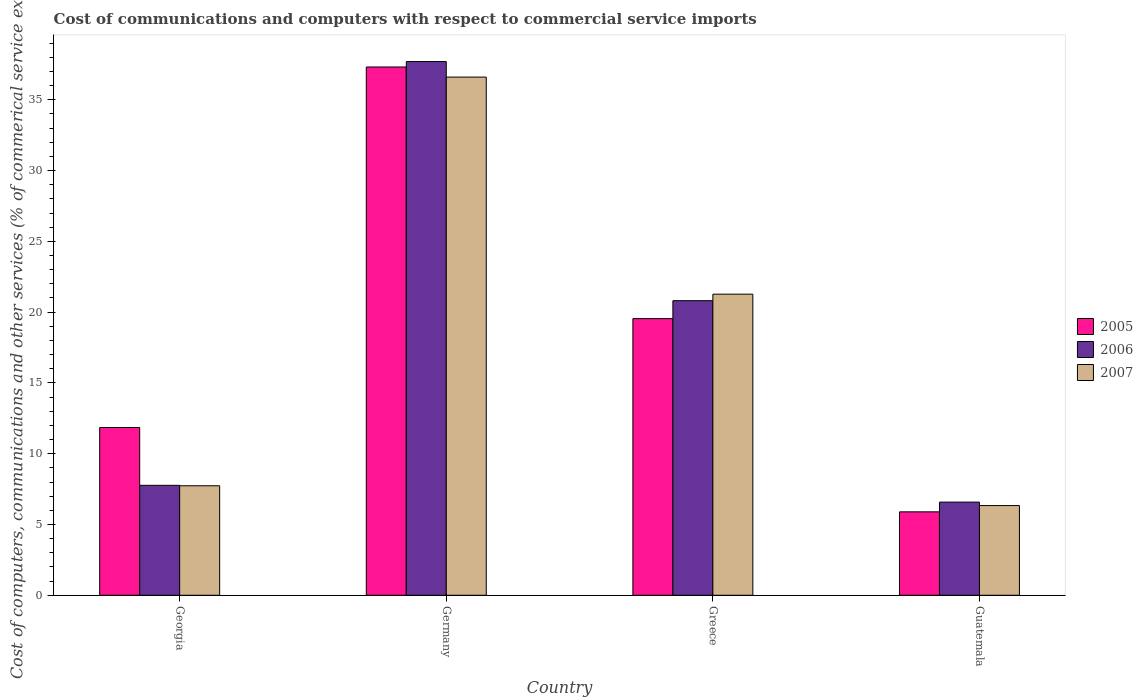How many bars are there on the 4th tick from the right?
Keep it short and to the point. 3. What is the label of the 4th group of bars from the left?
Your answer should be very brief. Guatemala. In how many cases, is the number of bars for a given country not equal to the number of legend labels?
Keep it short and to the point. 0. What is the cost of communications and computers in 2005 in Guatemala?
Your answer should be very brief. 5.89. Across all countries, what is the maximum cost of communications and computers in 2007?
Provide a short and direct response. 36.6. Across all countries, what is the minimum cost of communications and computers in 2006?
Give a very brief answer. 6.58. In which country was the cost of communications and computers in 2006 maximum?
Provide a short and direct response. Germany. In which country was the cost of communications and computers in 2007 minimum?
Keep it short and to the point. Guatemala. What is the total cost of communications and computers in 2005 in the graph?
Your response must be concise. 74.61. What is the difference between the cost of communications and computers in 2005 in Greece and that in Guatemala?
Keep it short and to the point. 13.65. What is the difference between the cost of communications and computers in 2005 in Guatemala and the cost of communications and computers in 2006 in Greece?
Offer a very short reply. -14.92. What is the average cost of communications and computers in 2005 per country?
Give a very brief answer. 18.65. What is the difference between the cost of communications and computers of/in 2006 and cost of communications and computers of/in 2005 in Guatemala?
Provide a short and direct response. 0.69. What is the ratio of the cost of communications and computers in 2005 in Germany to that in Greece?
Your answer should be compact. 1.91. Is the difference between the cost of communications and computers in 2006 in Georgia and Greece greater than the difference between the cost of communications and computers in 2005 in Georgia and Greece?
Keep it short and to the point. No. What is the difference between the highest and the second highest cost of communications and computers in 2005?
Your response must be concise. -7.69. What is the difference between the highest and the lowest cost of communications and computers in 2007?
Provide a succinct answer. 30.27. In how many countries, is the cost of communications and computers in 2006 greater than the average cost of communications and computers in 2006 taken over all countries?
Your answer should be very brief. 2. Is the sum of the cost of communications and computers in 2005 in Germany and Greece greater than the maximum cost of communications and computers in 2007 across all countries?
Keep it short and to the point. Yes. What does the 2nd bar from the left in Greece represents?
Your answer should be compact. 2006. Is it the case that in every country, the sum of the cost of communications and computers in 2007 and cost of communications and computers in 2006 is greater than the cost of communications and computers in 2005?
Offer a very short reply. Yes. How many countries are there in the graph?
Your answer should be very brief. 4. What is the difference between two consecutive major ticks on the Y-axis?
Your answer should be compact. 5. Where does the legend appear in the graph?
Provide a succinct answer. Center right. What is the title of the graph?
Keep it short and to the point. Cost of communications and computers with respect to commercial service imports. Does "1970" appear as one of the legend labels in the graph?
Offer a terse response. No. What is the label or title of the X-axis?
Your answer should be compact. Country. What is the label or title of the Y-axis?
Your answer should be very brief. Cost of computers, communications and other services (% of commerical service exports). What is the Cost of computers, communications and other services (% of commerical service exports) in 2005 in Georgia?
Make the answer very short. 11.85. What is the Cost of computers, communications and other services (% of commerical service exports) in 2006 in Georgia?
Provide a short and direct response. 7.77. What is the Cost of computers, communications and other services (% of commerical service exports) in 2007 in Georgia?
Your answer should be compact. 7.73. What is the Cost of computers, communications and other services (% of commerical service exports) of 2005 in Germany?
Give a very brief answer. 37.32. What is the Cost of computers, communications and other services (% of commerical service exports) of 2006 in Germany?
Your answer should be compact. 37.7. What is the Cost of computers, communications and other services (% of commerical service exports) in 2007 in Germany?
Offer a very short reply. 36.6. What is the Cost of computers, communications and other services (% of commerical service exports) of 2005 in Greece?
Offer a very short reply. 19.54. What is the Cost of computers, communications and other services (% of commerical service exports) in 2006 in Greece?
Offer a very short reply. 20.81. What is the Cost of computers, communications and other services (% of commerical service exports) of 2007 in Greece?
Your answer should be very brief. 21.27. What is the Cost of computers, communications and other services (% of commerical service exports) in 2005 in Guatemala?
Your response must be concise. 5.89. What is the Cost of computers, communications and other services (% of commerical service exports) in 2006 in Guatemala?
Keep it short and to the point. 6.58. What is the Cost of computers, communications and other services (% of commerical service exports) in 2007 in Guatemala?
Keep it short and to the point. 6.34. Across all countries, what is the maximum Cost of computers, communications and other services (% of commerical service exports) in 2005?
Provide a succinct answer. 37.32. Across all countries, what is the maximum Cost of computers, communications and other services (% of commerical service exports) in 2006?
Give a very brief answer. 37.7. Across all countries, what is the maximum Cost of computers, communications and other services (% of commerical service exports) in 2007?
Ensure brevity in your answer.  36.6. Across all countries, what is the minimum Cost of computers, communications and other services (% of commerical service exports) of 2005?
Provide a succinct answer. 5.89. Across all countries, what is the minimum Cost of computers, communications and other services (% of commerical service exports) in 2006?
Make the answer very short. 6.58. Across all countries, what is the minimum Cost of computers, communications and other services (% of commerical service exports) in 2007?
Your answer should be compact. 6.34. What is the total Cost of computers, communications and other services (% of commerical service exports) in 2005 in the graph?
Offer a terse response. 74.61. What is the total Cost of computers, communications and other services (% of commerical service exports) in 2006 in the graph?
Your response must be concise. 72.86. What is the total Cost of computers, communications and other services (% of commerical service exports) in 2007 in the graph?
Provide a short and direct response. 71.95. What is the difference between the Cost of computers, communications and other services (% of commerical service exports) in 2005 in Georgia and that in Germany?
Your answer should be very brief. -25.46. What is the difference between the Cost of computers, communications and other services (% of commerical service exports) of 2006 in Georgia and that in Germany?
Your response must be concise. -29.93. What is the difference between the Cost of computers, communications and other services (% of commerical service exports) of 2007 in Georgia and that in Germany?
Your answer should be very brief. -28.87. What is the difference between the Cost of computers, communications and other services (% of commerical service exports) in 2005 in Georgia and that in Greece?
Your response must be concise. -7.69. What is the difference between the Cost of computers, communications and other services (% of commerical service exports) in 2006 in Georgia and that in Greece?
Offer a terse response. -13.04. What is the difference between the Cost of computers, communications and other services (% of commerical service exports) of 2007 in Georgia and that in Greece?
Provide a short and direct response. -13.54. What is the difference between the Cost of computers, communications and other services (% of commerical service exports) in 2005 in Georgia and that in Guatemala?
Give a very brief answer. 5.96. What is the difference between the Cost of computers, communications and other services (% of commerical service exports) in 2006 in Georgia and that in Guatemala?
Offer a very short reply. 1.18. What is the difference between the Cost of computers, communications and other services (% of commerical service exports) of 2007 in Georgia and that in Guatemala?
Offer a terse response. 1.4. What is the difference between the Cost of computers, communications and other services (% of commerical service exports) in 2005 in Germany and that in Greece?
Provide a short and direct response. 17.77. What is the difference between the Cost of computers, communications and other services (% of commerical service exports) in 2006 in Germany and that in Greece?
Offer a terse response. 16.89. What is the difference between the Cost of computers, communications and other services (% of commerical service exports) of 2007 in Germany and that in Greece?
Ensure brevity in your answer.  15.33. What is the difference between the Cost of computers, communications and other services (% of commerical service exports) of 2005 in Germany and that in Guatemala?
Provide a short and direct response. 31.42. What is the difference between the Cost of computers, communications and other services (% of commerical service exports) in 2006 in Germany and that in Guatemala?
Ensure brevity in your answer.  31.12. What is the difference between the Cost of computers, communications and other services (% of commerical service exports) of 2007 in Germany and that in Guatemala?
Provide a succinct answer. 30.27. What is the difference between the Cost of computers, communications and other services (% of commerical service exports) of 2005 in Greece and that in Guatemala?
Your answer should be compact. 13.65. What is the difference between the Cost of computers, communications and other services (% of commerical service exports) of 2006 in Greece and that in Guatemala?
Keep it short and to the point. 14.23. What is the difference between the Cost of computers, communications and other services (% of commerical service exports) of 2007 in Greece and that in Guatemala?
Ensure brevity in your answer.  14.93. What is the difference between the Cost of computers, communications and other services (% of commerical service exports) in 2005 in Georgia and the Cost of computers, communications and other services (% of commerical service exports) in 2006 in Germany?
Your answer should be compact. -25.85. What is the difference between the Cost of computers, communications and other services (% of commerical service exports) of 2005 in Georgia and the Cost of computers, communications and other services (% of commerical service exports) of 2007 in Germany?
Your answer should be compact. -24.75. What is the difference between the Cost of computers, communications and other services (% of commerical service exports) in 2006 in Georgia and the Cost of computers, communications and other services (% of commerical service exports) in 2007 in Germany?
Your answer should be compact. -28.84. What is the difference between the Cost of computers, communications and other services (% of commerical service exports) of 2005 in Georgia and the Cost of computers, communications and other services (% of commerical service exports) of 2006 in Greece?
Make the answer very short. -8.96. What is the difference between the Cost of computers, communications and other services (% of commerical service exports) in 2005 in Georgia and the Cost of computers, communications and other services (% of commerical service exports) in 2007 in Greece?
Your response must be concise. -9.42. What is the difference between the Cost of computers, communications and other services (% of commerical service exports) in 2006 in Georgia and the Cost of computers, communications and other services (% of commerical service exports) in 2007 in Greece?
Give a very brief answer. -13.5. What is the difference between the Cost of computers, communications and other services (% of commerical service exports) in 2005 in Georgia and the Cost of computers, communications and other services (% of commerical service exports) in 2006 in Guatemala?
Your answer should be compact. 5.27. What is the difference between the Cost of computers, communications and other services (% of commerical service exports) in 2005 in Georgia and the Cost of computers, communications and other services (% of commerical service exports) in 2007 in Guatemala?
Your answer should be compact. 5.52. What is the difference between the Cost of computers, communications and other services (% of commerical service exports) in 2006 in Georgia and the Cost of computers, communications and other services (% of commerical service exports) in 2007 in Guatemala?
Offer a very short reply. 1.43. What is the difference between the Cost of computers, communications and other services (% of commerical service exports) of 2005 in Germany and the Cost of computers, communications and other services (% of commerical service exports) of 2006 in Greece?
Give a very brief answer. 16.51. What is the difference between the Cost of computers, communications and other services (% of commerical service exports) in 2005 in Germany and the Cost of computers, communications and other services (% of commerical service exports) in 2007 in Greece?
Make the answer very short. 16.05. What is the difference between the Cost of computers, communications and other services (% of commerical service exports) of 2006 in Germany and the Cost of computers, communications and other services (% of commerical service exports) of 2007 in Greece?
Your answer should be very brief. 16.43. What is the difference between the Cost of computers, communications and other services (% of commerical service exports) in 2005 in Germany and the Cost of computers, communications and other services (% of commerical service exports) in 2006 in Guatemala?
Keep it short and to the point. 30.74. What is the difference between the Cost of computers, communications and other services (% of commerical service exports) of 2005 in Germany and the Cost of computers, communications and other services (% of commerical service exports) of 2007 in Guatemala?
Your answer should be compact. 30.98. What is the difference between the Cost of computers, communications and other services (% of commerical service exports) in 2006 in Germany and the Cost of computers, communications and other services (% of commerical service exports) in 2007 in Guatemala?
Ensure brevity in your answer.  31.36. What is the difference between the Cost of computers, communications and other services (% of commerical service exports) in 2005 in Greece and the Cost of computers, communications and other services (% of commerical service exports) in 2006 in Guatemala?
Offer a terse response. 12.96. What is the difference between the Cost of computers, communications and other services (% of commerical service exports) in 2005 in Greece and the Cost of computers, communications and other services (% of commerical service exports) in 2007 in Guatemala?
Keep it short and to the point. 13.21. What is the difference between the Cost of computers, communications and other services (% of commerical service exports) in 2006 in Greece and the Cost of computers, communications and other services (% of commerical service exports) in 2007 in Guatemala?
Your answer should be compact. 14.47. What is the average Cost of computers, communications and other services (% of commerical service exports) of 2005 per country?
Keep it short and to the point. 18.65. What is the average Cost of computers, communications and other services (% of commerical service exports) of 2006 per country?
Make the answer very short. 18.21. What is the average Cost of computers, communications and other services (% of commerical service exports) in 2007 per country?
Provide a short and direct response. 17.99. What is the difference between the Cost of computers, communications and other services (% of commerical service exports) in 2005 and Cost of computers, communications and other services (% of commerical service exports) in 2006 in Georgia?
Ensure brevity in your answer.  4.09. What is the difference between the Cost of computers, communications and other services (% of commerical service exports) of 2005 and Cost of computers, communications and other services (% of commerical service exports) of 2007 in Georgia?
Ensure brevity in your answer.  4.12. What is the difference between the Cost of computers, communications and other services (% of commerical service exports) of 2006 and Cost of computers, communications and other services (% of commerical service exports) of 2007 in Georgia?
Give a very brief answer. 0.03. What is the difference between the Cost of computers, communications and other services (% of commerical service exports) of 2005 and Cost of computers, communications and other services (% of commerical service exports) of 2006 in Germany?
Ensure brevity in your answer.  -0.38. What is the difference between the Cost of computers, communications and other services (% of commerical service exports) in 2005 and Cost of computers, communications and other services (% of commerical service exports) in 2007 in Germany?
Make the answer very short. 0.71. What is the difference between the Cost of computers, communications and other services (% of commerical service exports) of 2006 and Cost of computers, communications and other services (% of commerical service exports) of 2007 in Germany?
Your answer should be very brief. 1.1. What is the difference between the Cost of computers, communications and other services (% of commerical service exports) in 2005 and Cost of computers, communications and other services (% of commerical service exports) in 2006 in Greece?
Provide a succinct answer. -1.27. What is the difference between the Cost of computers, communications and other services (% of commerical service exports) of 2005 and Cost of computers, communications and other services (% of commerical service exports) of 2007 in Greece?
Give a very brief answer. -1.73. What is the difference between the Cost of computers, communications and other services (% of commerical service exports) of 2006 and Cost of computers, communications and other services (% of commerical service exports) of 2007 in Greece?
Your answer should be very brief. -0.46. What is the difference between the Cost of computers, communications and other services (% of commerical service exports) of 2005 and Cost of computers, communications and other services (% of commerical service exports) of 2006 in Guatemala?
Offer a very short reply. -0.69. What is the difference between the Cost of computers, communications and other services (% of commerical service exports) of 2005 and Cost of computers, communications and other services (% of commerical service exports) of 2007 in Guatemala?
Give a very brief answer. -0.44. What is the difference between the Cost of computers, communications and other services (% of commerical service exports) of 2006 and Cost of computers, communications and other services (% of commerical service exports) of 2007 in Guatemala?
Give a very brief answer. 0.25. What is the ratio of the Cost of computers, communications and other services (% of commerical service exports) in 2005 in Georgia to that in Germany?
Keep it short and to the point. 0.32. What is the ratio of the Cost of computers, communications and other services (% of commerical service exports) in 2006 in Georgia to that in Germany?
Offer a terse response. 0.21. What is the ratio of the Cost of computers, communications and other services (% of commerical service exports) of 2007 in Georgia to that in Germany?
Keep it short and to the point. 0.21. What is the ratio of the Cost of computers, communications and other services (% of commerical service exports) of 2005 in Georgia to that in Greece?
Your answer should be compact. 0.61. What is the ratio of the Cost of computers, communications and other services (% of commerical service exports) of 2006 in Georgia to that in Greece?
Ensure brevity in your answer.  0.37. What is the ratio of the Cost of computers, communications and other services (% of commerical service exports) of 2007 in Georgia to that in Greece?
Ensure brevity in your answer.  0.36. What is the ratio of the Cost of computers, communications and other services (% of commerical service exports) of 2005 in Georgia to that in Guatemala?
Offer a very short reply. 2.01. What is the ratio of the Cost of computers, communications and other services (% of commerical service exports) of 2006 in Georgia to that in Guatemala?
Your response must be concise. 1.18. What is the ratio of the Cost of computers, communications and other services (% of commerical service exports) in 2007 in Georgia to that in Guatemala?
Provide a succinct answer. 1.22. What is the ratio of the Cost of computers, communications and other services (% of commerical service exports) of 2005 in Germany to that in Greece?
Your response must be concise. 1.91. What is the ratio of the Cost of computers, communications and other services (% of commerical service exports) in 2006 in Germany to that in Greece?
Ensure brevity in your answer.  1.81. What is the ratio of the Cost of computers, communications and other services (% of commerical service exports) of 2007 in Germany to that in Greece?
Your response must be concise. 1.72. What is the ratio of the Cost of computers, communications and other services (% of commerical service exports) of 2005 in Germany to that in Guatemala?
Provide a succinct answer. 6.33. What is the ratio of the Cost of computers, communications and other services (% of commerical service exports) in 2006 in Germany to that in Guatemala?
Provide a succinct answer. 5.73. What is the ratio of the Cost of computers, communications and other services (% of commerical service exports) in 2007 in Germany to that in Guatemala?
Offer a very short reply. 5.78. What is the ratio of the Cost of computers, communications and other services (% of commerical service exports) of 2005 in Greece to that in Guatemala?
Your response must be concise. 3.32. What is the ratio of the Cost of computers, communications and other services (% of commerical service exports) of 2006 in Greece to that in Guatemala?
Your answer should be very brief. 3.16. What is the ratio of the Cost of computers, communications and other services (% of commerical service exports) of 2007 in Greece to that in Guatemala?
Your answer should be very brief. 3.36. What is the difference between the highest and the second highest Cost of computers, communications and other services (% of commerical service exports) in 2005?
Your answer should be compact. 17.77. What is the difference between the highest and the second highest Cost of computers, communications and other services (% of commerical service exports) in 2006?
Your response must be concise. 16.89. What is the difference between the highest and the second highest Cost of computers, communications and other services (% of commerical service exports) of 2007?
Provide a short and direct response. 15.33. What is the difference between the highest and the lowest Cost of computers, communications and other services (% of commerical service exports) in 2005?
Your response must be concise. 31.42. What is the difference between the highest and the lowest Cost of computers, communications and other services (% of commerical service exports) in 2006?
Keep it short and to the point. 31.12. What is the difference between the highest and the lowest Cost of computers, communications and other services (% of commerical service exports) of 2007?
Ensure brevity in your answer.  30.27. 